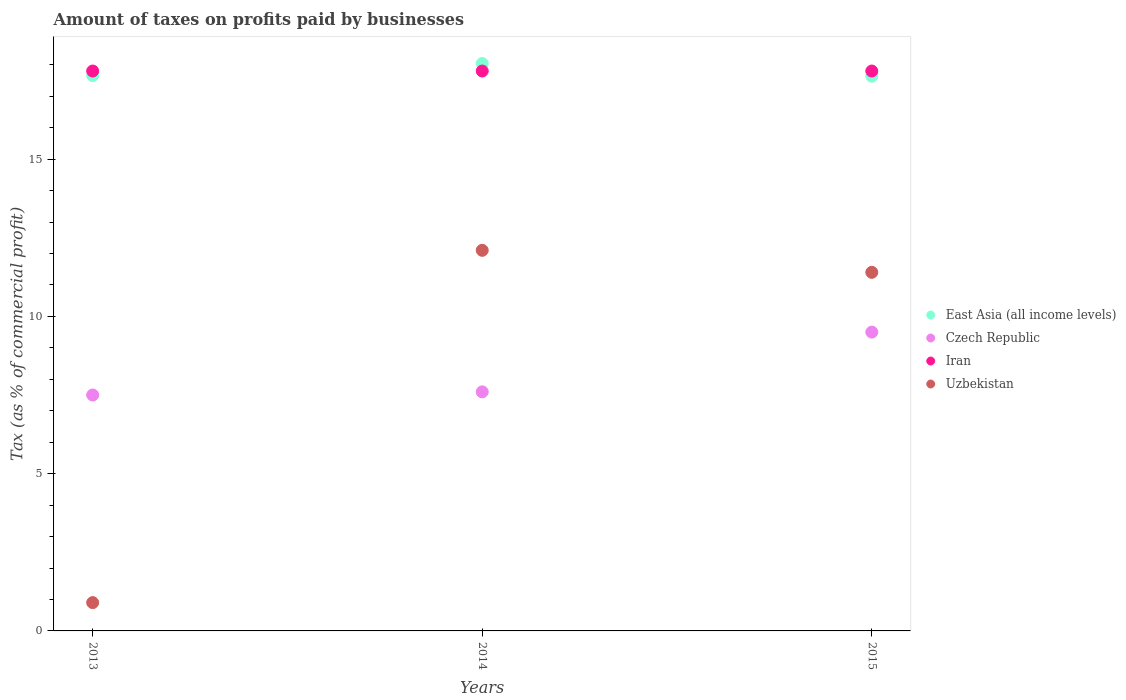Is the number of dotlines equal to the number of legend labels?
Give a very brief answer. Yes. What is the percentage of taxes paid by businesses in East Asia (all income levels) in 2015?
Provide a short and direct response. 17.63. Across all years, what is the minimum percentage of taxes paid by businesses in Uzbekistan?
Provide a short and direct response. 0.9. In which year was the percentage of taxes paid by businesses in Iran maximum?
Give a very brief answer. 2013. In which year was the percentage of taxes paid by businesses in East Asia (all income levels) minimum?
Give a very brief answer. 2015. What is the total percentage of taxes paid by businesses in Czech Republic in the graph?
Offer a terse response. 24.6. What is the difference between the percentage of taxes paid by businesses in Czech Republic in 2014 and that in 2015?
Ensure brevity in your answer.  -1.9. What is the difference between the percentage of taxes paid by businesses in Uzbekistan in 2013 and the percentage of taxes paid by businesses in Iran in 2014?
Offer a very short reply. -16.9. What is the average percentage of taxes paid by businesses in Uzbekistan per year?
Your response must be concise. 8.13. In the year 2013, what is the difference between the percentage of taxes paid by businesses in Czech Republic and percentage of taxes paid by businesses in Iran?
Provide a succinct answer. -10.3. In how many years, is the percentage of taxes paid by businesses in Czech Republic greater than 10 %?
Provide a succinct answer. 0. What is the ratio of the percentage of taxes paid by businesses in Czech Republic in 2014 to that in 2015?
Keep it short and to the point. 0.8. Is the percentage of taxes paid by businesses in Iran in 2014 less than that in 2015?
Offer a very short reply. No. What is the difference between the highest and the second highest percentage of taxes paid by businesses in Uzbekistan?
Your answer should be compact. 0.7. What is the difference between the highest and the lowest percentage of taxes paid by businesses in Czech Republic?
Your response must be concise. 2. Is it the case that in every year, the sum of the percentage of taxes paid by businesses in Uzbekistan and percentage of taxes paid by businesses in Czech Republic  is greater than the sum of percentage of taxes paid by businesses in Iran and percentage of taxes paid by businesses in East Asia (all income levels)?
Your response must be concise. No. Is it the case that in every year, the sum of the percentage of taxes paid by businesses in East Asia (all income levels) and percentage of taxes paid by businesses in Iran  is greater than the percentage of taxes paid by businesses in Uzbekistan?
Your response must be concise. Yes. Does the percentage of taxes paid by businesses in Uzbekistan monotonically increase over the years?
Keep it short and to the point. No. Is the percentage of taxes paid by businesses in East Asia (all income levels) strictly less than the percentage of taxes paid by businesses in Iran over the years?
Provide a succinct answer. No. How many years are there in the graph?
Ensure brevity in your answer.  3. Are the values on the major ticks of Y-axis written in scientific E-notation?
Your answer should be compact. No. Does the graph contain any zero values?
Offer a terse response. No. Does the graph contain grids?
Provide a succinct answer. No. How many legend labels are there?
Ensure brevity in your answer.  4. How are the legend labels stacked?
Your answer should be very brief. Vertical. What is the title of the graph?
Make the answer very short. Amount of taxes on profits paid by businesses. What is the label or title of the Y-axis?
Your response must be concise. Tax (as % of commercial profit). What is the Tax (as % of commercial profit) of East Asia (all income levels) in 2013?
Make the answer very short. 17.66. What is the Tax (as % of commercial profit) of Iran in 2013?
Offer a terse response. 17.8. What is the Tax (as % of commercial profit) of East Asia (all income levels) in 2014?
Offer a terse response. 18.04. What is the Tax (as % of commercial profit) of Iran in 2014?
Offer a terse response. 17.8. What is the Tax (as % of commercial profit) in East Asia (all income levels) in 2015?
Keep it short and to the point. 17.63. What is the Tax (as % of commercial profit) of Czech Republic in 2015?
Ensure brevity in your answer.  9.5. What is the Tax (as % of commercial profit) of Iran in 2015?
Your answer should be compact. 17.8. What is the Tax (as % of commercial profit) of Uzbekistan in 2015?
Keep it short and to the point. 11.4. Across all years, what is the maximum Tax (as % of commercial profit) of East Asia (all income levels)?
Keep it short and to the point. 18.04. Across all years, what is the maximum Tax (as % of commercial profit) in Czech Republic?
Offer a very short reply. 9.5. Across all years, what is the maximum Tax (as % of commercial profit) in Iran?
Your answer should be compact. 17.8. Across all years, what is the minimum Tax (as % of commercial profit) in East Asia (all income levels)?
Your response must be concise. 17.63. Across all years, what is the minimum Tax (as % of commercial profit) of Czech Republic?
Make the answer very short. 7.5. What is the total Tax (as % of commercial profit) of East Asia (all income levels) in the graph?
Offer a very short reply. 53.33. What is the total Tax (as % of commercial profit) of Czech Republic in the graph?
Give a very brief answer. 24.6. What is the total Tax (as % of commercial profit) in Iran in the graph?
Your answer should be compact. 53.4. What is the total Tax (as % of commercial profit) of Uzbekistan in the graph?
Offer a very short reply. 24.4. What is the difference between the Tax (as % of commercial profit) of East Asia (all income levels) in 2013 and that in 2014?
Give a very brief answer. -0.38. What is the difference between the Tax (as % of commercial profit) of Czech Republic in 2013 and that in 2014?
Offer a terse response. -0.1. What is the difference between the Tax (as % of commercial profit) of East Asia (all income levels) in 2013 and that in 2015?
Offer a terse response. 0.02. What is the difference between the Tax (as % of commercial profit) of Czech Republic in 2013 and that in 2015?
Make the answer very short. -2. What is the difference between the Tax (as % of commercial profit) in Iran in 2013 and that in 2015?
Provide a short and direct response. 0. What is the difference between the Tax (as % of commercial profit) in Uzbekistan in 2013 and that in 2015?
Your answer should be very brief. -10.5. What is the difference between the Tax (as % of commercial profit) of East Asia (all income levels) in 2014 and that in 2015?
Your response must be concise. 0.4. What is the difference between the Tax (as % of commercial profit) in Czech Republic in 2014 and that in 2015?
Make the answer very short. -1.9. What is the difference between the Tax (as % of commercial profit) of East Asia (all income levels) in 2013 and the Tax (as % of commercial profit) of Czech Republic in 2014?
Your answer should be very brief. 10.06. What is the difference between the Tax (as % of commercial profit) of East Asia (all income levels) in 2013 and the Tax (as % of commercial profit) of Iran in 2014?
Your answer should be compact. -0.14. What is the difference between the Tax (as % of commercial profit) of East Asia (all income levels) in 2013 and the Tax (as % of commercial profit) of Uzbekistan in 2014?
Make the answer very short. 5.56. What is the difference between the Tax (as % of commercial profit) in Czech Republic in 2013 and the Tax (as % of commercial profit) in Uzbekistan in 2014?
Provide a short and direct response. -4.6. What is the difference between the Tax (as % of commercial profit) of East Asia (all income levels) in 2013 and the Tax (as % of commercial profit) of Czech Republic in 2015?
Provide a short and direct response. 8.16. What is the difference between the Tax (as % of commercial profit) in East Asia (all income levels) in 2013 and the Tax (as % of commercial profit) in Iran in 2015?
Ensure brevity in your answer.  -0.14. What is the difference between the Tax (as % of commercial profit) in East Asia (all income levels) in 2013 and the Tax (as % of commercial profit) in Uzbekistan in 2015?
Give a very brief answer. 6.26. What is the difference between the Tax (as % of commercial profit) of Czech Republic in 2013 and the Tax (as % of commercial profit) of Iran in 2015?
Provide a short and direct response. -10.3. What is the difference between the Tax (as % of commercial profit) of Czech Republic in 2013 and the Tax (as % of commercial profit) of Uzbekistan in 2015?
Offer a very short reply. -3.9. What is the difference between the Tax (as % of commercial profit) in Iran in 2013 and the Tax (as % of commercial profit) in Uzbekistan in 2015?
Your answer should be compact. 6.4. What is the difference between the Tax (as % of commercial profit) of East Asia (all income levels) in 2014 and the Tax (as % of commercial profit) of Czech Republic in 2015?
Offer a very short reply. 8.54. What is the difference between the Tax (as % of commercial profit) of East Asia (all income levels) in 2014 and the Tax (as % of commercial profit) of Iran in 2015?
Keep it short and to the point. 0.24. What is the difference between the Tax (as % of commercial profit) of East Asia (all income levels) in 2014 and the Tax (as % of commercial profit) of Uzbekistan in 2015?
Keep it short and to the point. 6.64. What is the difference between the Tax (as % of commercial profit) of Iran in 2014 and the Tax (as % of commercial profit) of Uzbekistan in 2015?
Give a very brief answer. 6.4. What is the average Tax (as % of commercial profit) of East Asia (all income levels) per year?
Make the answer very short. 17.78. What is the average Tax (as % of commercial profit) in Czech Republic per year?
Provide a short and direct response. 8.2. What is the average Tax (as % of commercial profit) in Uzbekistan per year?
Your response must be concise. 8.13. In the year 2013, what is the difference between the Tax (as % of commercial profit) of East Asia (all income levels) and Tax (as % of commercial profit) of Czech Republic?
Make the answer very short. 10.16. In the year 2013, what is the difference between the Tax (as % of commercial profit) in East Asia (all income levels) and Tax (as % of commercial profit) in Iran?
Your response must be concise. -0.14. In the year 2013, what is the difference between the Tax (as % of commercial profit) in East Asia (all income levels) and Tax (as % of commercial profit) in Uzbekistan?
Offer a very short reply. 16.76. In the year 2014, what is the difference between the Tax (as % of commercial profit) of East Asia (all income levels) and Tax (as % of commercial profit) of Czech Republic?
Keep it short and to the point. 10.44. In the year 2014, what is the difference between the Tax (as % of commercial profit) of East Asia (all income levels) and Tax (as % of commercial profit) of Iran?
Provide a succinct answer. 0.24. In the year 2014, what is the difference between the Tax (as % of commercial profit) in East Asia (all income levels) and Tax (as % of commercial profit) in Uzbekistan?
Your answer should be very brief. 5.94. In the year 2014, what is the difference between the Tax (as % of commercial profit) of Czech Republic and Tax (as % of commercial profit) of Uzbekistan?
Ensure brevity in your answer.  -4.5. In the year 2015, what is the difference between the Tax (as % of commercial profit) of East Asia (all income levels) and Tax (as % of commercial profit) of Czech Republic?
Make the answer very short. 8.13. In the year 2015, what is the difference between the Tax (as % of commercial profit) in East Asia (all income levels) and Tax (as % of commercial profit) in Iran?
Your response must be concise. -0.17. In the year 2015, what is the difference between the Tax (as % of commercial profit) in East Asia (all income levels) and Tax (as % of commercial profit) in Uzbekistan?
Your response must be concise. 6.23. In the year 2015, what is the difference between the Tax (as % of commercial profit) in Czech Republic and Tax (as % of commercial profit) in Iran?
Give a very brief answer. -8.3. What is the ratio of the Tax (as % of commercial profit) of East Asia (all income levels) in 2013 to that in 2014?
Provide a short and direct response. 0.98. What is the ratio of the Tax (as % of commercial profit) in Uzbekistan in 2013 to that in 2014?
Keep it short and to the point. 0.07. What is the ratio of the Tax (as % of commercial profit) of East Asia (all income levels) in 2013 to that in 2015?
Provide a succinct answer. 1. What is the ratio of the Tax (as % of commercial profit) of Czech Republic in 2013 to that in 2015?
Your response must be concise. 0.79. What is the ratio of the Tax (as % of commercial profit) of Iran in 2013 to that in 2015?
Give a very brief answer. 1. What is the ratio of the Tax (as % of commercial profit) of Uzbekistan in 2013 to that in 2015?
Keep it short and to the point. 0.08. What is the ratio of the Tax (as % of commercial profit) in East Asia (all income levels) in 2014 to that in 2015?
Ensure brevity in your answer.  1.02. What is the ratio of the Tax (as % of commercial profit) of Iran in 2014 to that in 2015?
Give a very brief answer. 1. What is the ratio of the Tax (as % of commercial profit) of Uzbekistan in 2014 to that in 2015?
Provide a succinct answer. 1.06. What is the difference between the highest and the second highest Tax (as % of commercial profit) of East Asia (all income levels)?
Ensure brevity in your answer.  0.38. What is the difference between the highest and the second highest Tax (as % of commercial profit) of Uzbekistan?
Your response must be concise. 0.7. What is the difference between the highest and the lowest Tax (as % of commercial profit) in East Asia (all income levels)?
Your answer should be compact. 0.4. What is the difference between the highest and the lowest Tax (as % of commercial profit) of Czech Republic?
Keep it short and to the point. 2. What is the difference between the highest and the lowest Tax (as % of commercial profit) of Iran?
Make the answer very short. 0. What is the difference between the highest and the lowest Tax (as % of commercial profit) in Uzbekistan?
Provide a short and direct response. 11.2. 